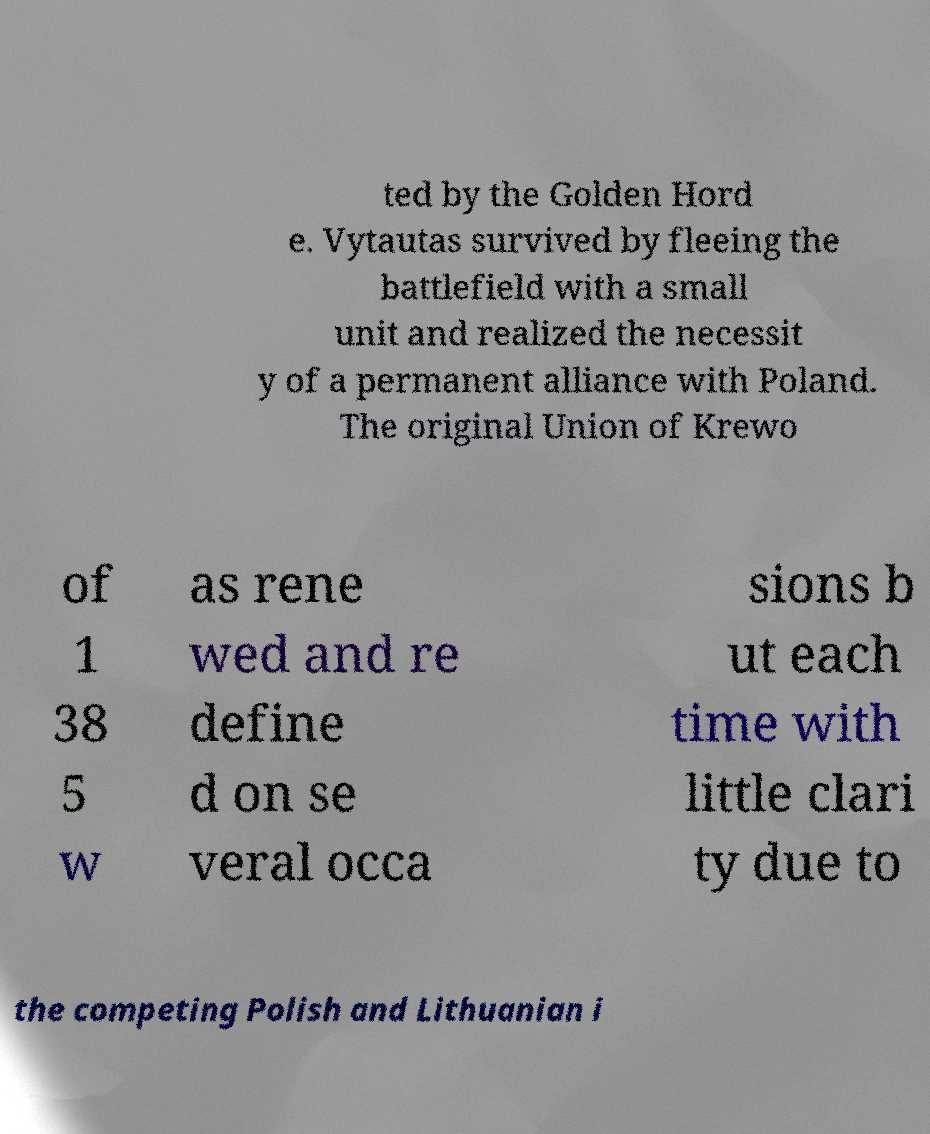For documentation purposes, I need the text within this image transcribed. Could you provide that? ted by the Golden Hord e. Vytautas survived by fleeing the battlefield with a small unit and realized the necessit y of a permanent alliance with Poland. The original Union of Krewo of 1 38 5 w as rene wed and re define d on se veral occa sions b ut each time with little clari ty due to the competing Polish and Lithuanian i 